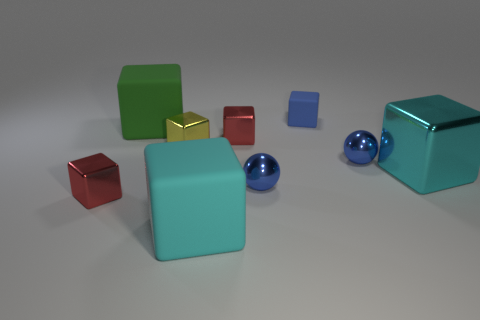Subtract all blue blocks. How many blocks are left? 6 Subtract all yellow cubes. How many cubes are left? 6 Subtract all purple cubes. Subtract all red spheres. How many cubes are left? 7 Subtract all spheres. How many objects are left? 7 Add 6 large cyan matte cubes. How many large cyan matte cubes are left? 7 Add 2 red things. How many red things exist? 4 Subtract 0 gray spheres. How many objects are left? 9 Subtract all big cyan blocks. Subtract all green rubber blocks. How many objects are left? 6 